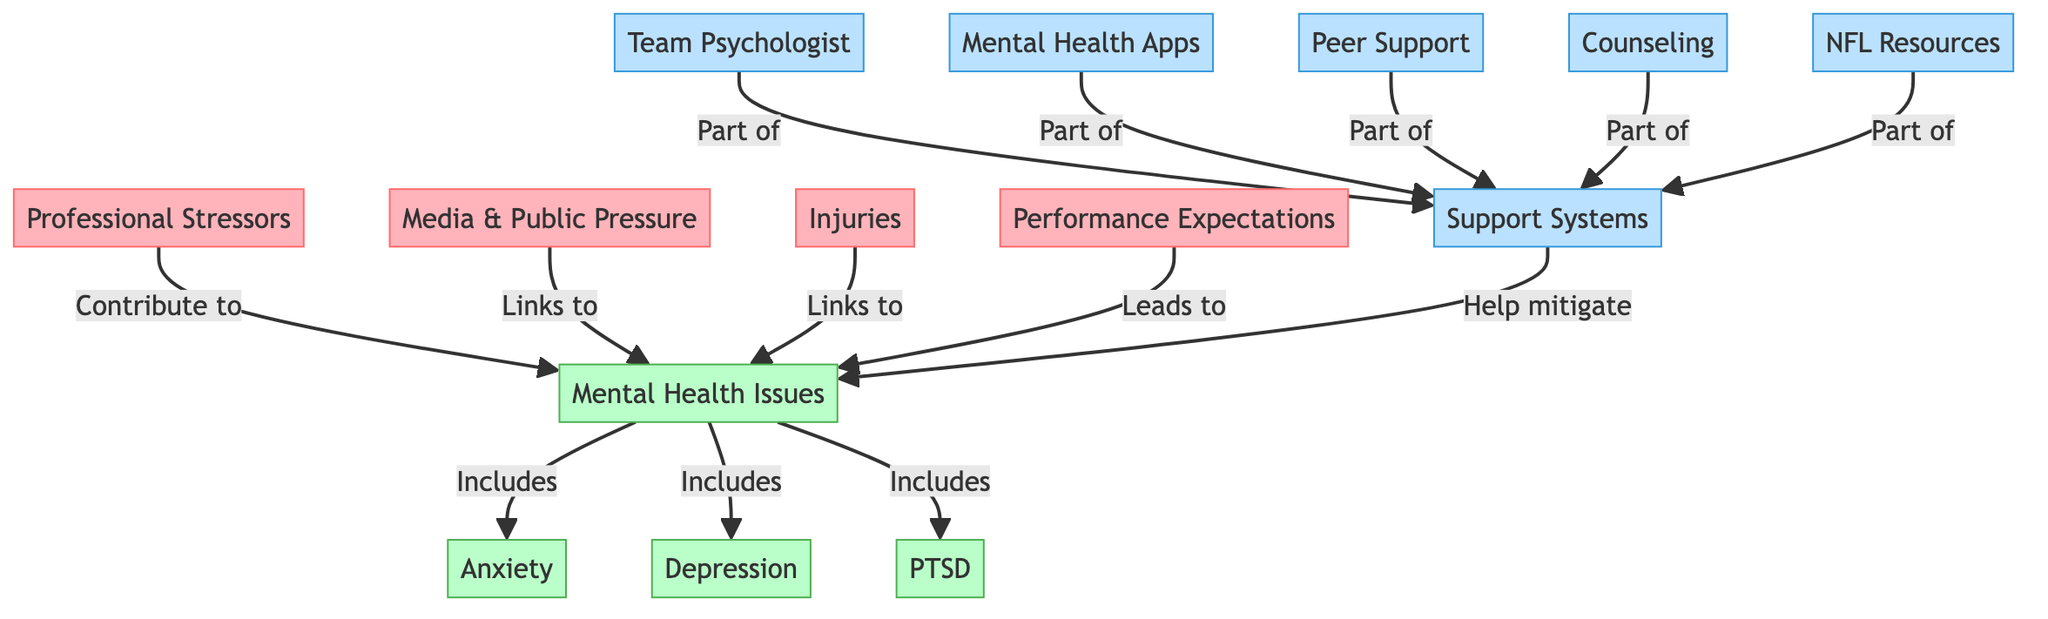What are the three main professional stressors listed in the diagram? The diagram identifies three main professional stressors: Media & Public Pressure, Injuries, and Performance Expectations. These stressors are directly connected to the node 'Professional Stressors.'
Answer: Media & Public Pressure, Injuries, Performance Expectations How many mental health issues are included in this diagram? The diagram shows three mental health issues: Anxiety, Depression, and PTSD, which branch from the node 'Mental Health Issues.'
Answer: Three Which support system is directly linked to team psychologists? The diagram indicates that Team Psychologist is part of the broader category of Support Systems and helps mitigate mental health issues.
Answer: Support Systems What mental health issue is associated with performance expectations? The connection in the diagram shows that Performance Expectations leads to Mental Health Issues, specifically Anxiety, Depression, and PTSD. However, it does not specify which one exclusively, but it is primarily linked to increased anxiety and pressure.
Answer: Mental Health Issues How do peer support systems relate to mental health issues? Peer Support is indicated in the diagram as a part of the Support Systems that help mitigate Mental Health Issues, demonstrating that having peer support can help reduce the impact of such issues.
Answer: Help mitigate What is the overall effect of professional stressors on mental health issues? The diagram illustrates that professional stressors contribute to mental health issues, leading to conditions like anxiety, depression, and PTSD. This causal relationship is clearly defined by the arrows connecting the nodes.
Answer: Contribute to Which resource is specifically mentioned alongside counseling in the support systems? The diagram highlights that Counseling and NFL Resources are both part of the Support Systems available for mental health challenges, indicating that they serve similar supportive functions.
Answer: NFL Resources Which type of mental health issue is linked to injuries? The diagram shows that Injuries are directly linked to Mental Health Issues, including conditions like Anxiety and Depression, emphasizing how physical injuries can lead to mental challenges.
Answer: Mental Health Issues 